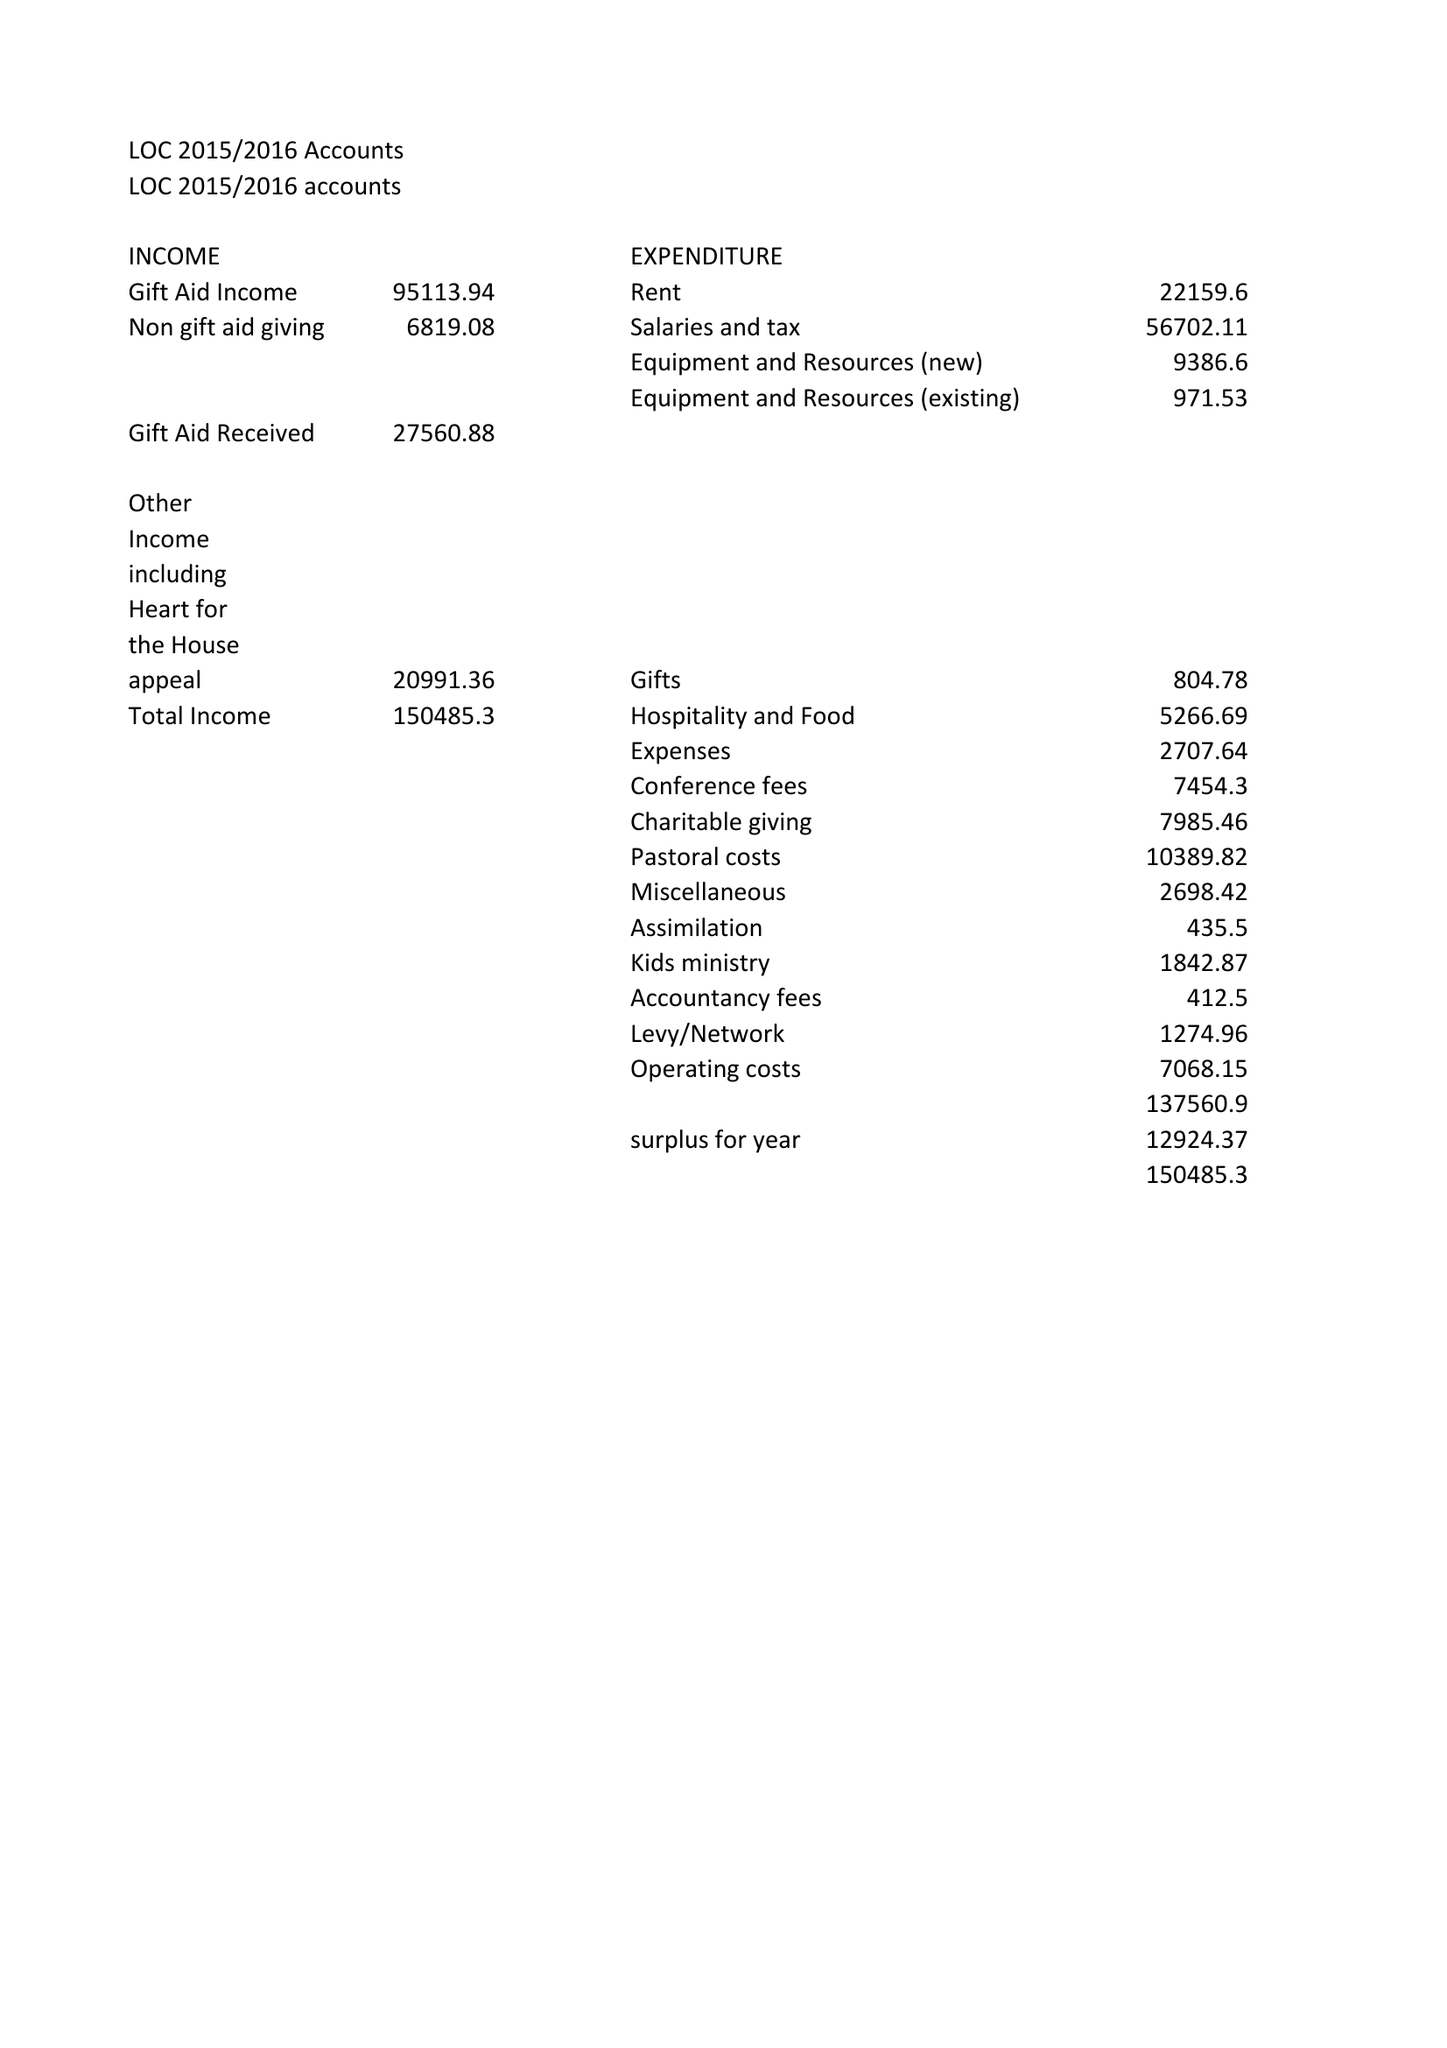What is the value for the charity_number?
Answer the question using a single word or phrase. 1137479 